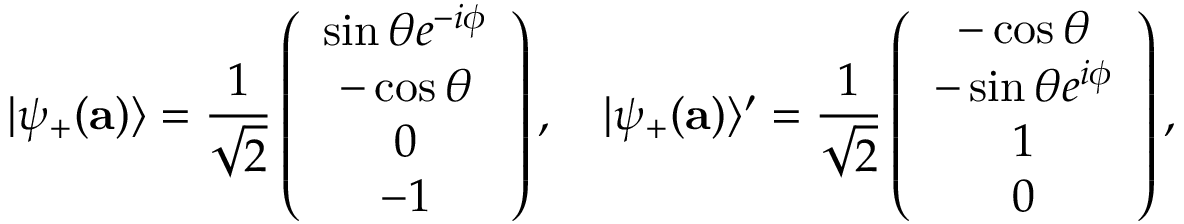Convert formula to latex. <formula><loc_0><loc_0><loc_500><loc_500>| \psi _ { + } ( { a } ) \rangle = \frac { 1 } { \sqrt { 2 } } \left ( \begin{array} { c } { { \sin \theta e ^ { - i \phi } } } \\ { - \cos \theta } \\ { 0 } \\ { - 1 } \end{array} \right ) , | \psi _ { + } ( { a } ) \rangle ^ { \prime } = \frac { 1 } { \sqrt { 2 } } \left ( \begin{array} { c } { - \cos \theta } \\ { { - \sin \theta e ^ { i \phi } } } \\ { 1 } \\ { 0 } \end{array} \right ) ,</formula> 